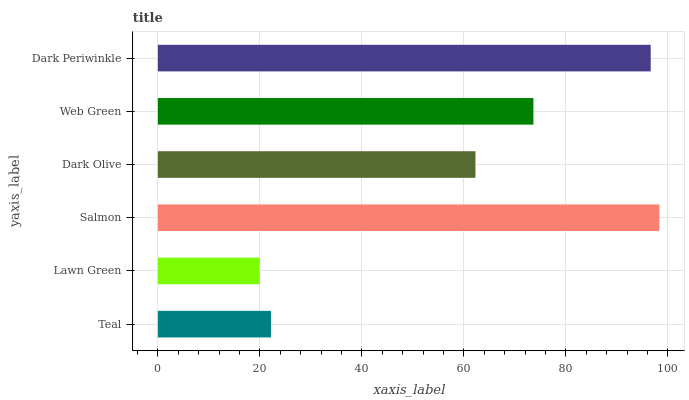Is Lawn Green the minimum?
Answer yes or no. Yes. Is Salmon the maximum?
Answer yes or no. Yes. Is Salmon the minimum?
Answer yes or no. No. Is Lawn Green the maximum?
Answer yes or no. No. Is Salmon greater than Lawn Green?
Answer yes or no. Yes. Is Lawn Green less than Salmon?
Answer yes or no. Yes. Is Lawn Green greater than Salmon?
Answer yes or no. No. Is Salmon less than Lawn Green?
Answer yes or no. No. Is Web Green the high median?
Answer yes or no. Yes. Is Dark Olive the low median?
Answer yes or no. Yes. Is Dark Olive the high median?
Answer yes or no. No. Is Teal the low median?
Answer yes or no. No. 